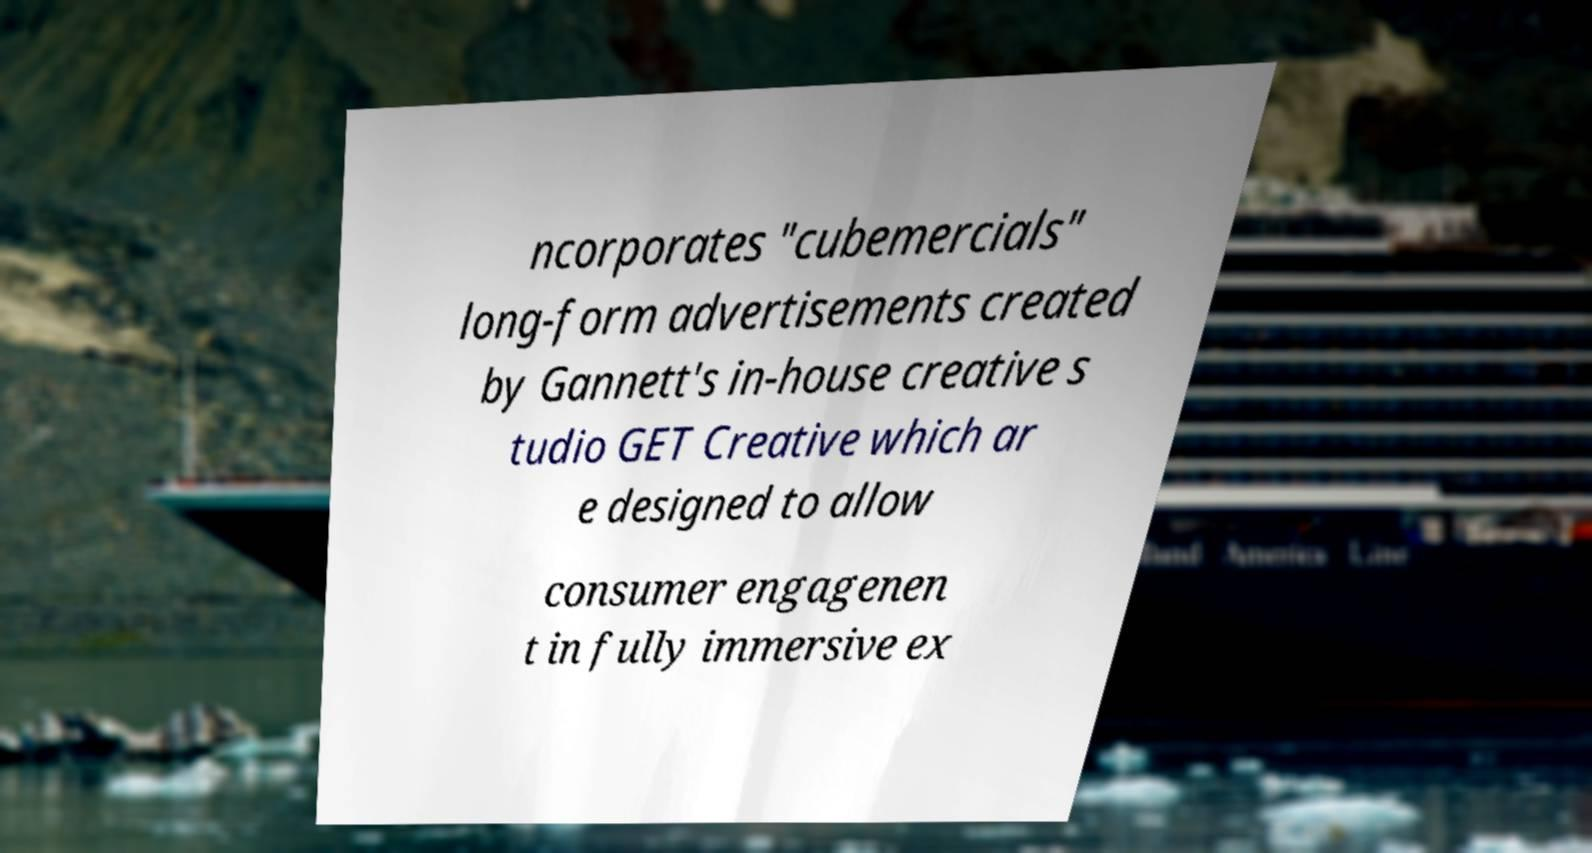Could you extract and type out the text from this image? ncorporates "cubemercials" long-form advertisements created by Gannett's in-house creative s tudio GET Creative which ar e designed to allow consumer engagenen t in fully immersive ex 